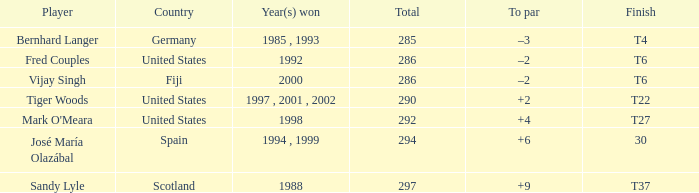Which player has +2 to par? Tiger Woods. 